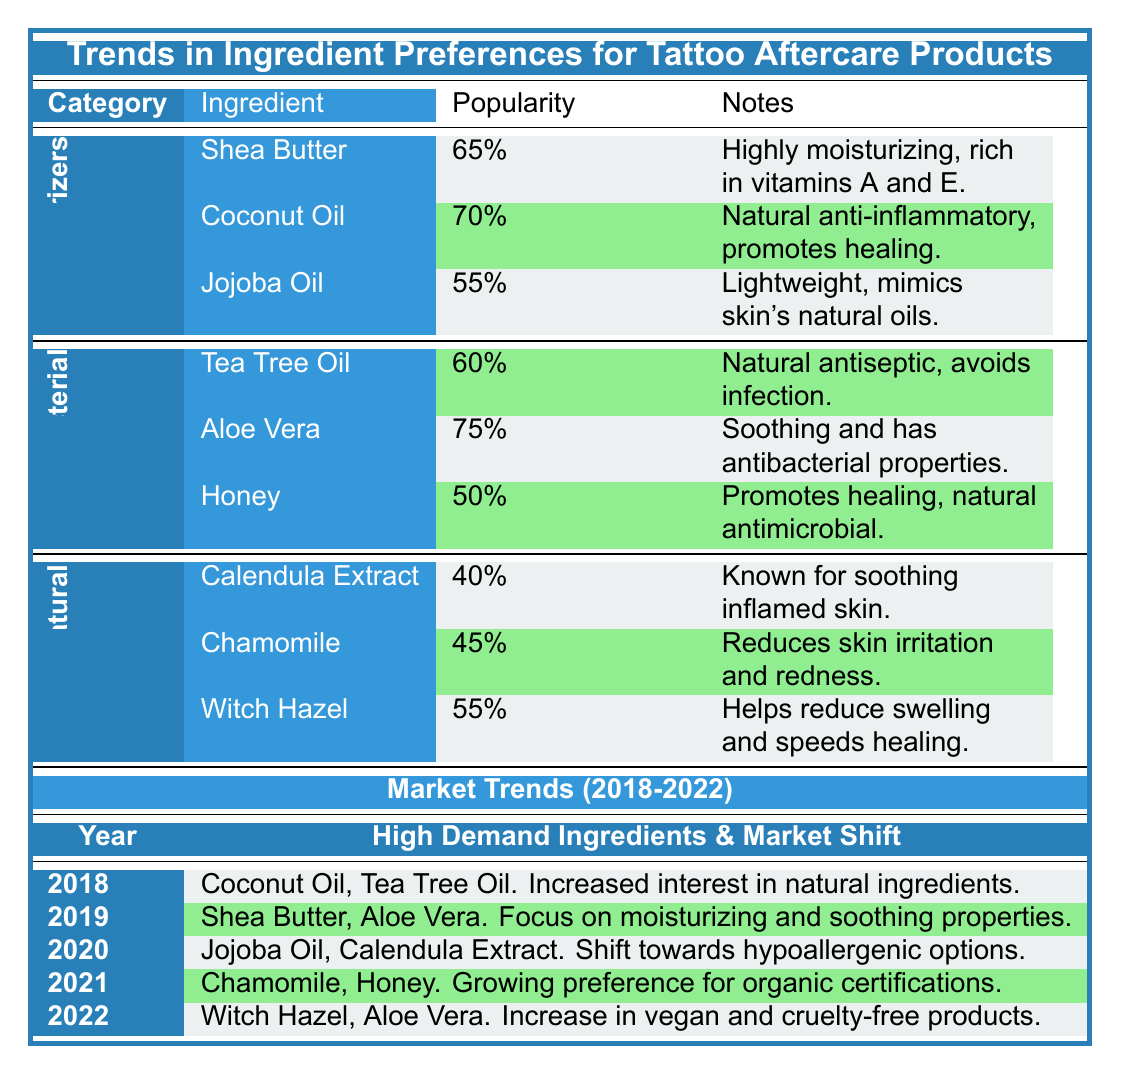What is the popularity percentage of Aloe Vera as an antibacterial agent? According to the table, Aloe Vera has a popularity percentage of 75.
Answer: 75 Which moisturizer has the lowest popularity? By checking the Moisturizers section, Jojoba Oil has the lowest popularity with 55.
Answer: Jojoba Oil What are the high-demand ingredients in 2021? The table lists Chamomile and Honey as the high-demand ingredients for the year 2021.
Answer: Chamomile and Honey Is Coconut Oil more popular than Tea Tree Oil? The popularity of Coconut Oil is 70, while the popularity of Tea Tree Oil is 60. Since 70 is greater than 60, the answer is yes.
Answer: Yes What is the average popularity of the Natural Ingredients category? The popularity values for Natural Ingredients are 40 (Calendula Extract), 45 (Chamomile), and 55 (Witch Hazel). Adding these gives 40 + 45 + 55 = 140, and dividing by 3 gives an average of 140/3 = approximately 46.67.
Answer: 46.67 Which year had a shift towards hypoallergenic options, and what were the high-demand ingredients for that year? The year 2020 experienced a shift toward hypoallergenic options, with Jojoba Oil and Calendula Extract listed as high-demand ingredients.
Answer: 2020: Jojoba Oil, Calendula Extract Is Witch Hazel included in the high-demand ingredients of 2018? In the 2018 row, the high-demand ingredients are Coconut Oil and Tea Tree Oil. Since Witch Hazel is not listed, the answer is no.
Answer: No Which antibacterial agent had the lowest popularity? The popularity values for antibacterial agents are 60 (Tea Tree Oil), 75 (Aloe Vera), and 50 (Honey). Honey has the lowest popularity at 50.
Answer: Honey 